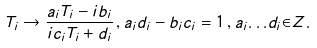<formula> <loc_0><loc_0><loc_500><loc_500>T _ { i } \rightarrow \frac { a _ { i } T _ { i } - i b _ { i } } { i c _ { i } T _ { i } + d _ { i } } \, , a _ { i } d _ { i } - b _ { i } c _ { i } = 1 \, , a _ { i } { \dots } d _ { i } { \in } Z .</formula> 